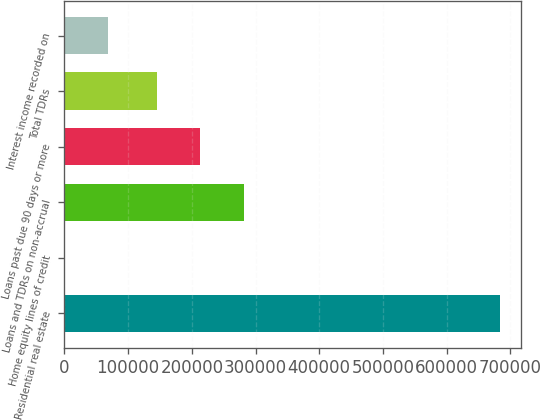<chart> <loc_0><loc_0><loc_500><loc_500><bar_chart><fcel>Residential real estate<fcel>Home equity lines of credit<fcel>Loans and TDRs on non-accrual<fcel>Loans past due 90 days or more<fcel>Total TDRs<fcel>Interest income recorded on<nl><fcel>683452<fcel>232<fcel>281621<fcel>213299<fcel>144977<fcel>68554<nl></chart> 